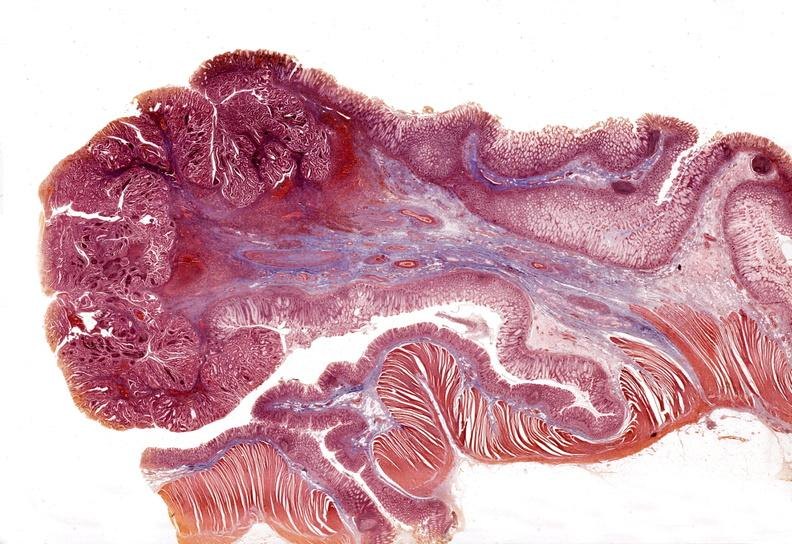does fibrotic lesion show stomach, adenomatous polyp and malignant focus?
Answer the question using a single word or phrase. No 